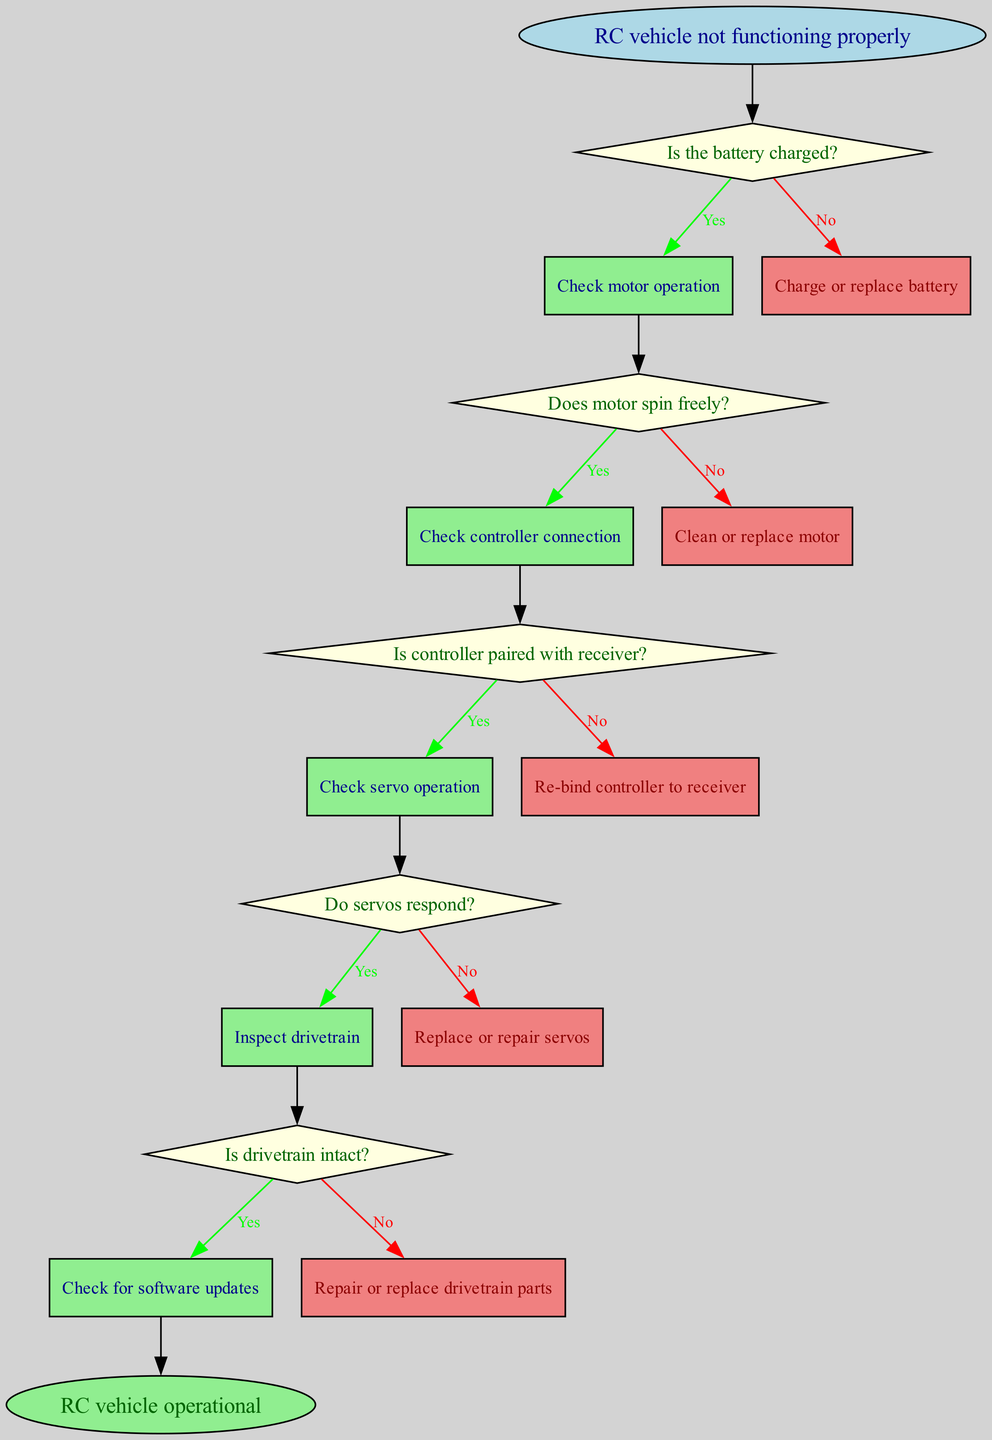What is the starting point of the flowchart? The starting point, indicated as "start", is the node labeled "RC vehicle not functioning properly". It is the first item displayed in the diagram and connects to the first decision point.
Answer: RC vehicle not functioning properly How many decision nodes are present in the flowchart? By counting the diamond-shaped nodes that pose questions, we find five decision nodes about different aspects of troubleshooting. Each node corresponds to a specific question in the troubleshooting process.
Answer: 5 What is the outcome if the battery is charged? Following the "Yes" path from the first decision about the battery, the next action is to "Check motor operation". This action indicates that the troubleshooting process will proceed to check if the motor is operating correctly.
Answer: Check motor operation What action should be taken if servos do not respond? The path leading from the decision node checking servo response leads to the action of "Replace or repair servos". This indicates that if the servos are unresponsive, they need to be addressed specifically in this way.
Answer: Replace or repair servos What is the final outcome of the flowchart? The last node in the flowchart that indicates the end of the troubleshooting process is labeled "RC vehicle operational". This signifies that after following the entire process, the intended final state of the RC vehicle is operational.
Answer: RC vehicle operational What should be done after confirming that the drivetrain is intact? The flowchart shows that after confirming the drivetrain is intact, the next recommendation is to "Check for software updates". This means that if no physical issues are found in the drivetrain, software might need attention.
Answer: Check for software updates Which node requires re-binding of the controller? The node that specifies re-binding is reached when the first check of whether the controller is paired with the receiver returns "No". This indicates that the controller is not communicating correctly, thus requiring this action.
Answer: Re-bind controller to receiver If the motor does not spin freely, what is the recommended action? The flow leads from the question about motor operation spinning freely to the action "Clean or replace motor". This indicates that the troubleshooting strategy must focus on the motor itself when this condition fails.
Answer: Clean or replace motor 